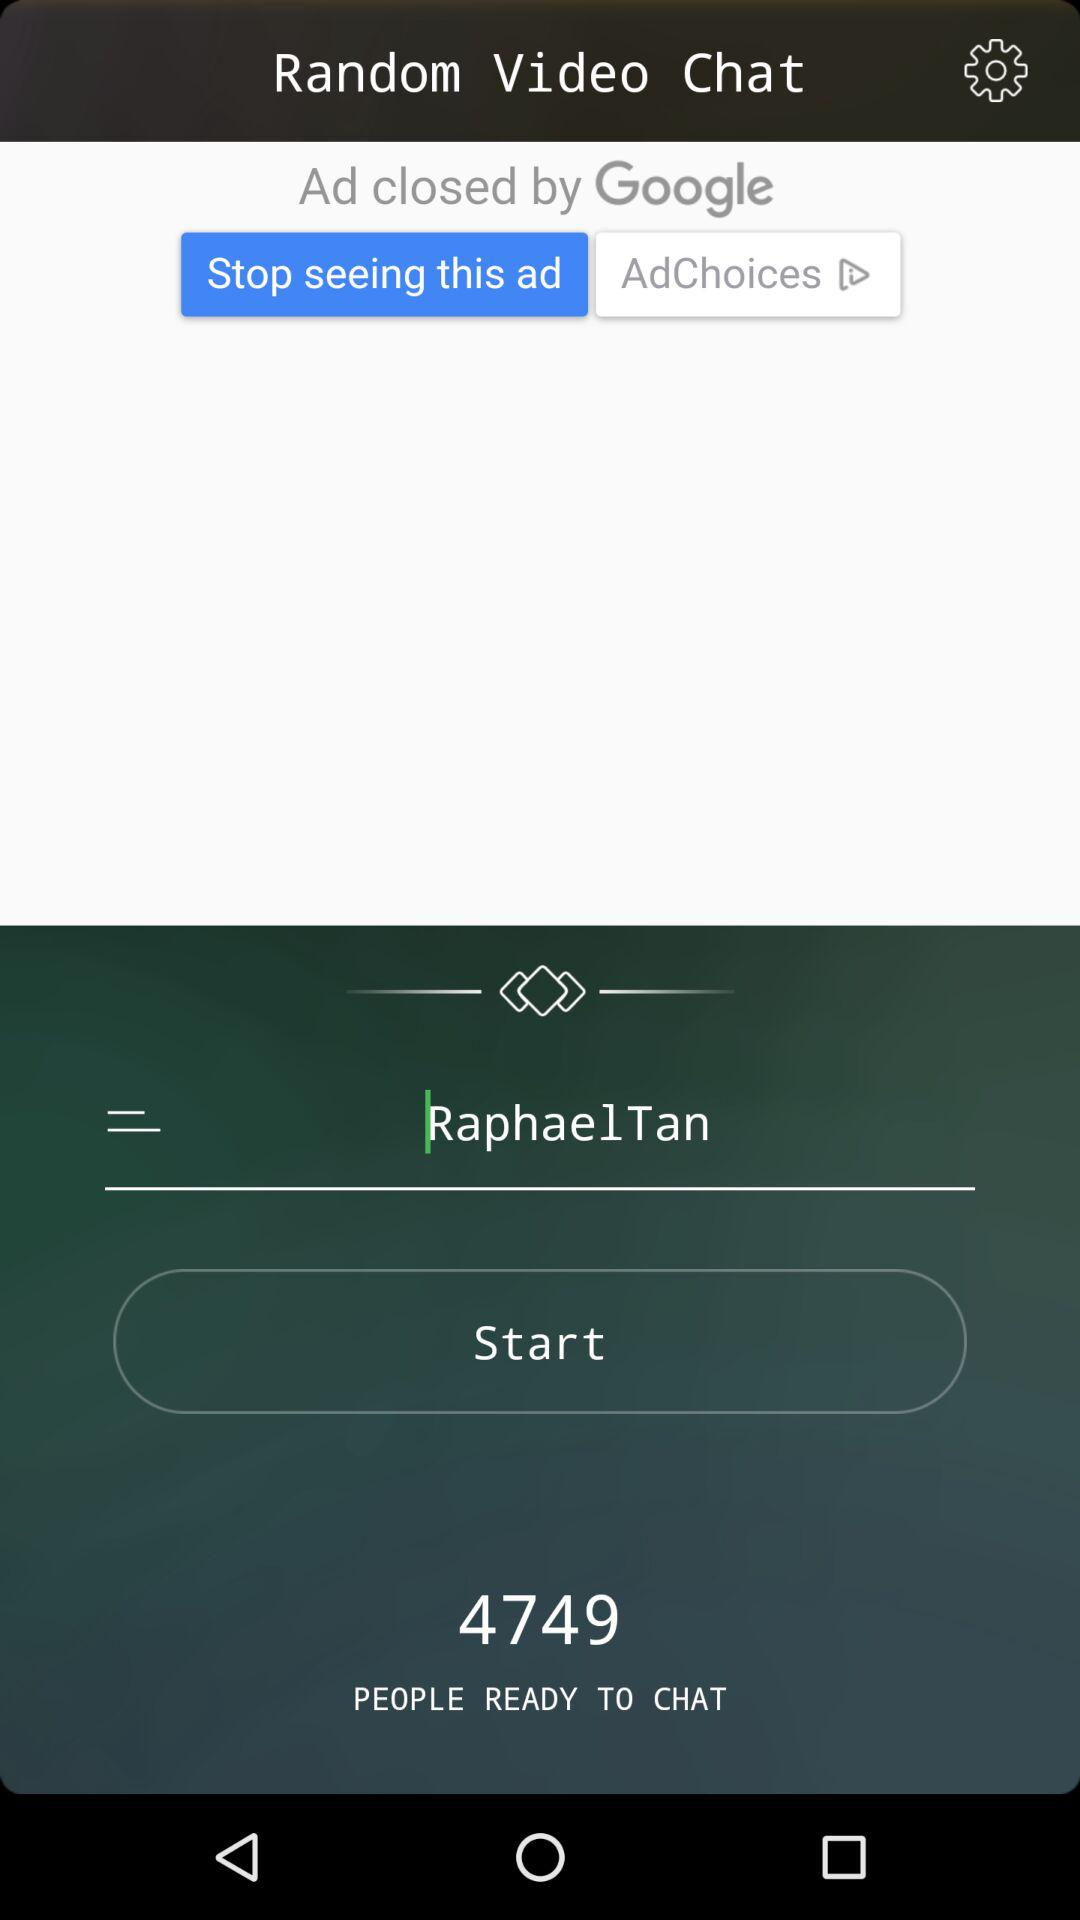What is the name of the user? The name of the user is Raphael Tan. 